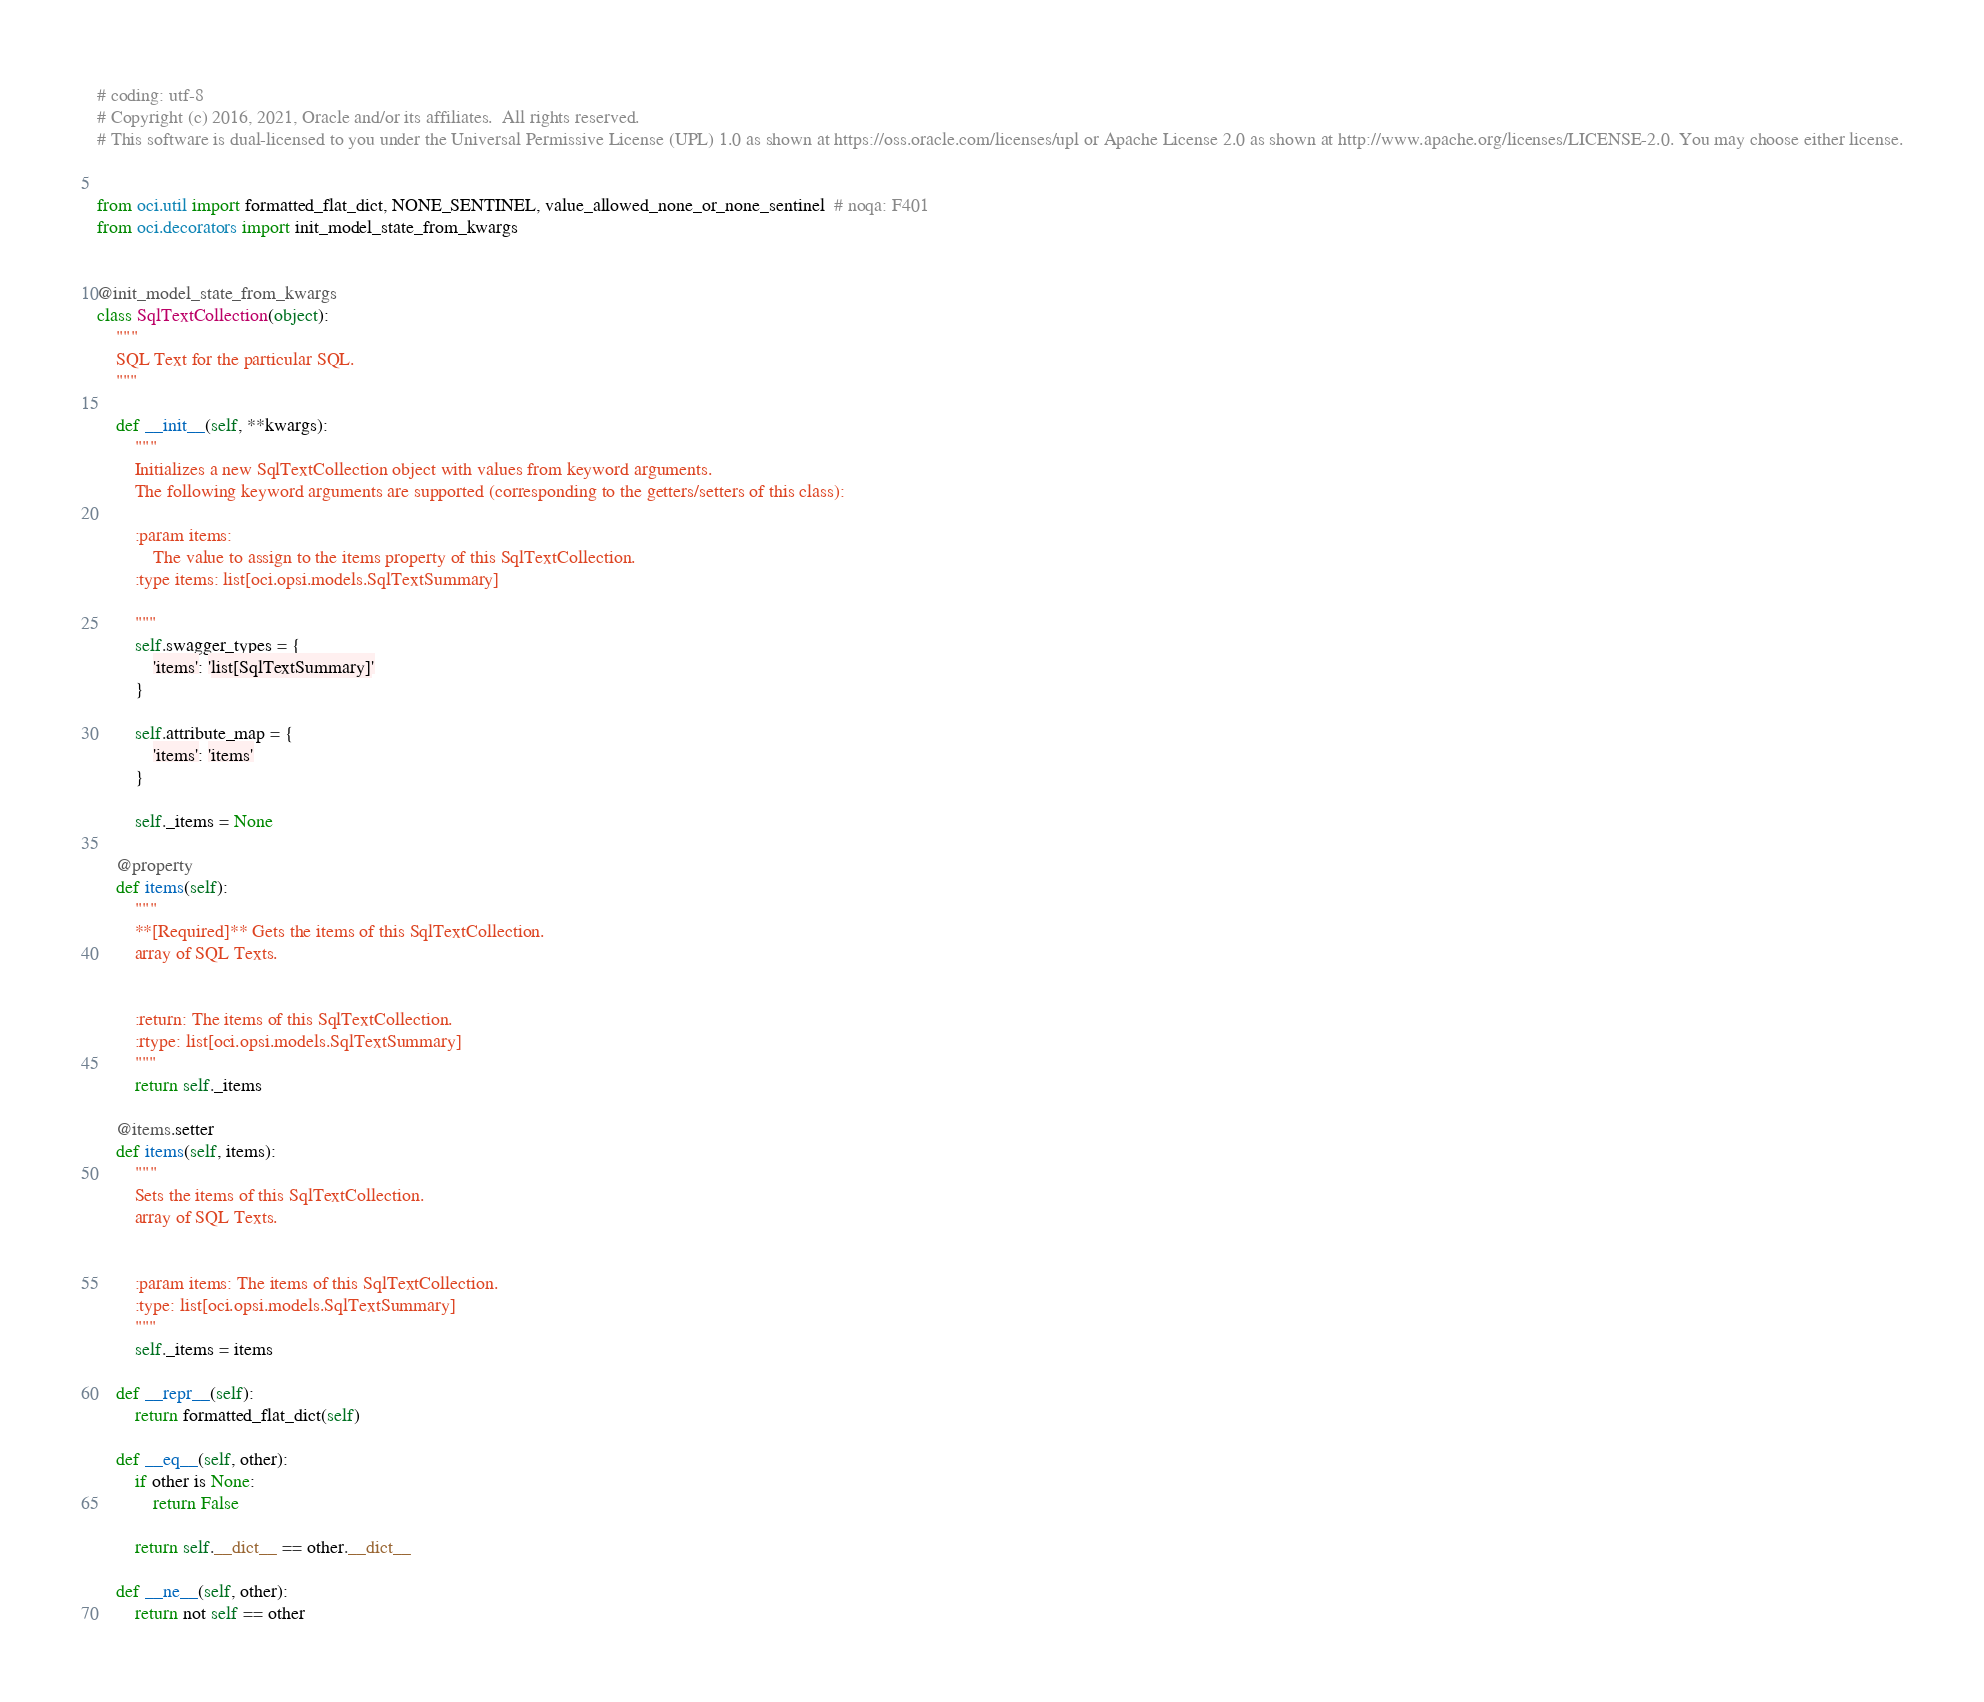<code> <loc_0><loc_0><loc_500><loc_500><_Python_># coding: utf-8
# Copyright (c) 2016, 2021, Oracle and/or its affiliates.  All rights reserved.
# This software is dual-licensed to you under the Universal Permissive License (UPL) 1.0 as shown at https://oss.oracle.com/licenses/upl or Apache License 2.0 as shown at http://www.apache.org/licenses/LICENSE-2.0. You may choose either license.


from oci.util import formatted_flat_dict, NONE_SENTINEL, value_allowed_none_or_none_sentinel  # noqa: F401
from oci.decorators import init_model_state_from_kwargs


@init_model_state_from_kwargs
class SqlTextCollection(object):
    """
    SQL Text for the particular SQL.
    """

    def __init__(self, **kwargs):
        """
        Initializes a new SqlTextCollection object with values from keyword arguments.
        The following keyword arguments are supported (corresponding to the getters/setters of this class):

        :param items:
            The value to assign to the items property of this SqlTextCollection.
        :type items: list[oci.opsi.models.SqlTextSummary]

        """
        self.swagger_types = {
            'items': 'list[SqlTextSummary]'
        }

        self.attribute_map = {
            'items': 'items'
        }

        self._items = None

    @property
    def items(self):
        """
        **[Required]** Gets the items of this SqlTextCollection.
        array of SQL Texts.


        :return: The items of this SqlTextCollection.
        :rtype: list[oci.opsi.models.SqlTextSummary]
        """
        return self._items

    @items.setter
    def items(self, items):
        """
        Sets the items of this SqlTextCollection.
        array of SQL Texts.


        :param items: The items of this SqlTextCollection.
        :type: list[oci.opsi.models.SqlTextSummary]
        """
        self._items = items

    def __repr__(self):
        return formatted_flat_dict(self)

    def __eq__(self, other):
        if other is None:
            return False

        return self.__dict__ == other.__dict__

    def __ne__(self, other):
        return not self == other
</code> 